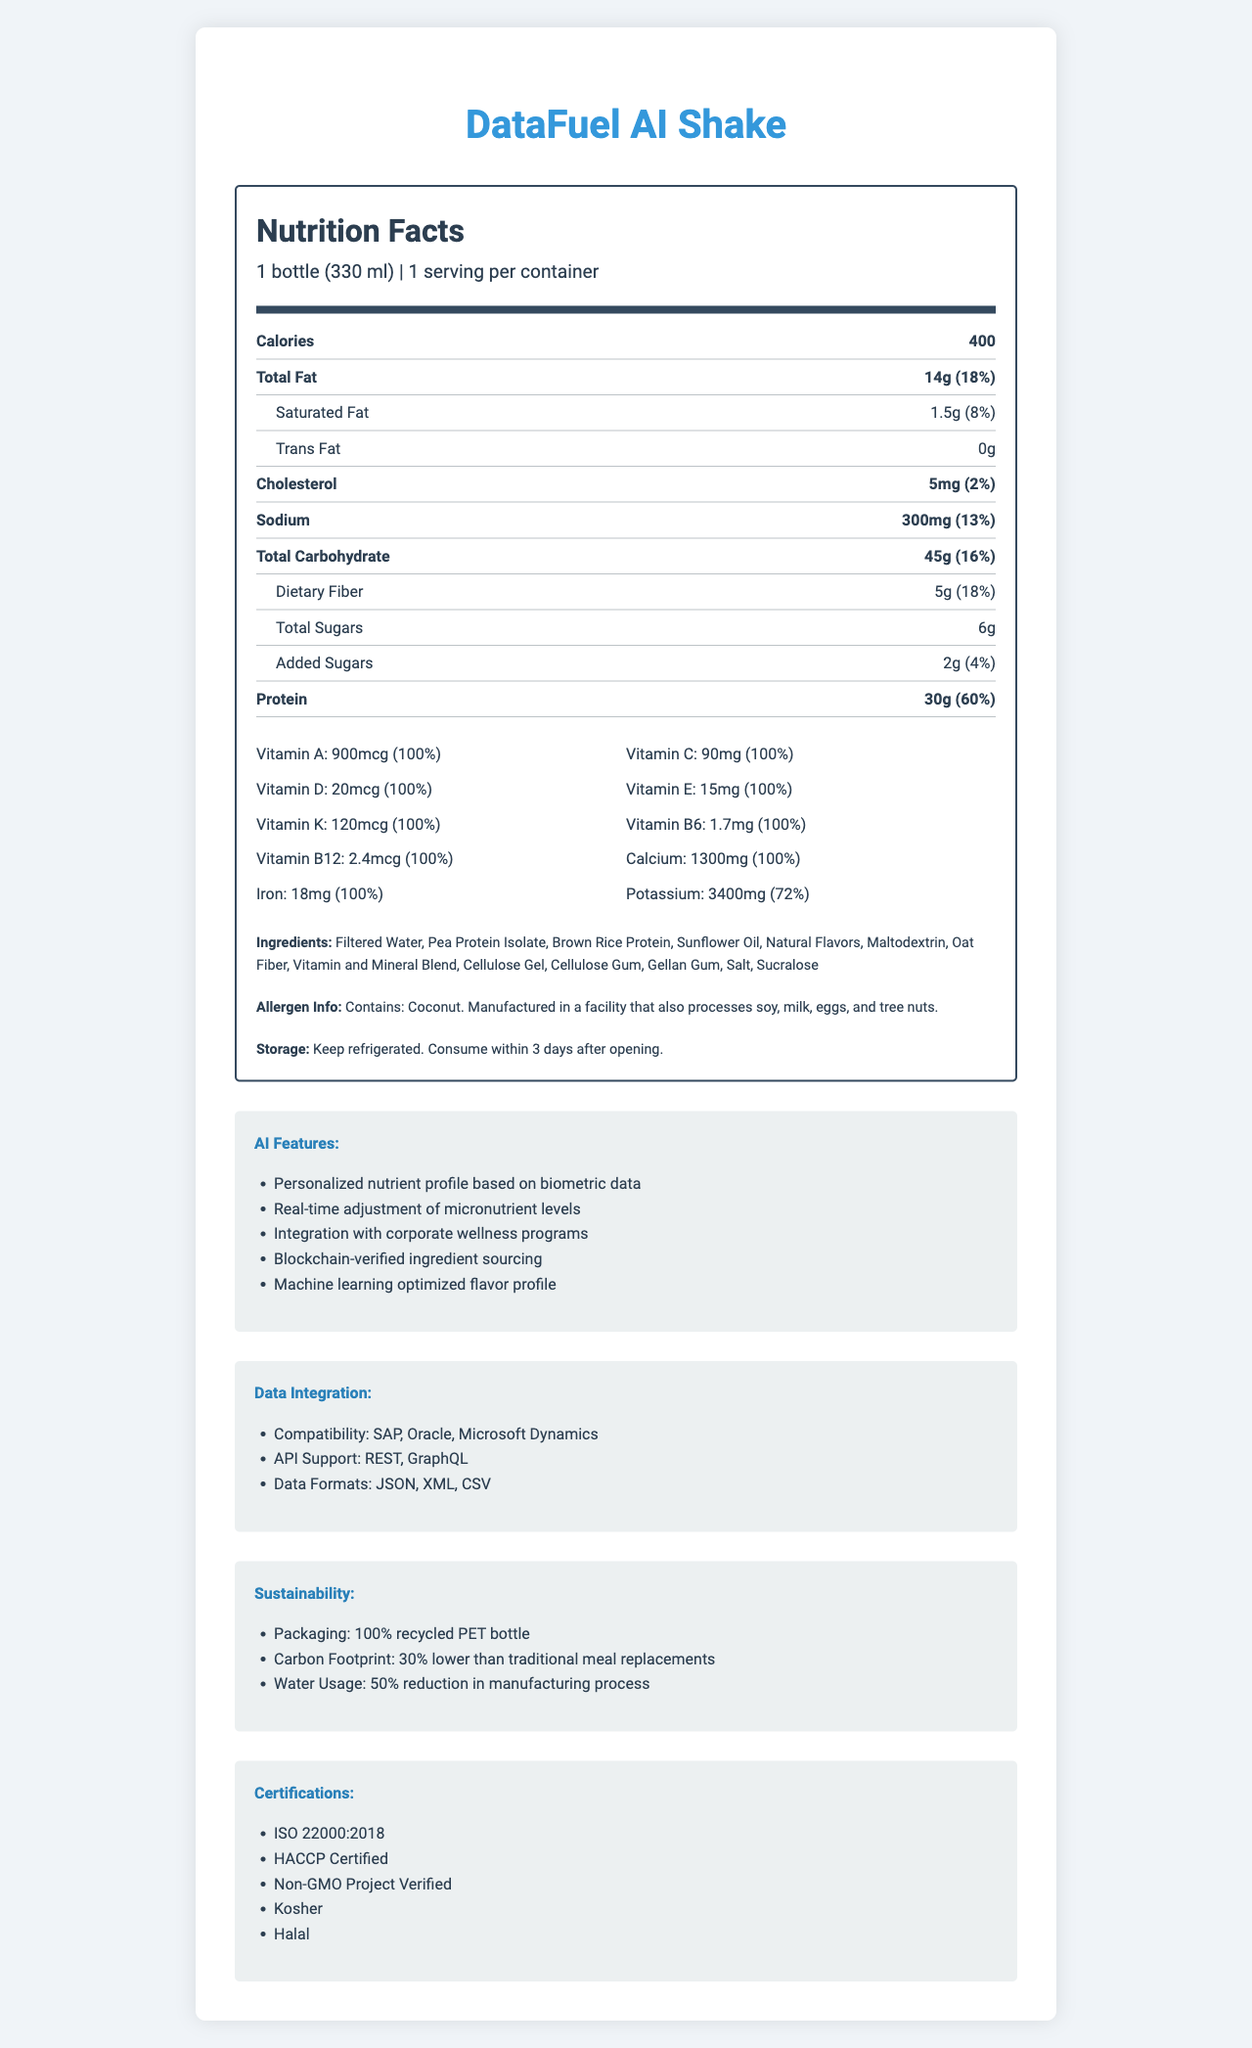what is the serving size for DataFuel AI Shake? The serving size is clearly mentioned in the section describing the serving information.
Answer: 1 bottle (330 ml) how many calories does one serving of DataFuel AI Shake contain? The calorie content is prominently listed under the main nutrients section.
Answer: 400 what is the amount of total fat in one serving? The amount of total fat is listed under the main nutrients section.
Answer: 14g how much added sugar is in one serving of DataFuel AI Shake? The amount of added sugars is specified in the sub-nutrient section.
Answer: 2g what is the daily value percentage of protein in one serving? The daily value percentage for protein is mentioned next to the protein amount.
Answer: 60% which of the following vitamins/minerals has a daily value of 100%? A. Vitamin A B. Vitamin C C. Calcium D. All of the above The document indicates that Vitamin A, Vitamin C, and Calcium each have a daily value of 100%.
Answer: D. All of the above which feature is not included in the AI functionalities? A. Personalized nutrient profile B. Real-time adjustment of micronutrient levels C. Blockchain-verified ingredient sourcing D. Automatic restocking The listed AI features do not mention anything about automatic restocking.
Answer: D. Automatic restocking is DataFuel AI Shake compatible with Microsoft Dynamics? Under data integration, it mentions compatibility with Microsoft Dynamics.
Answer: Yes summarize the key aspects of the DataFuel AI Shake. This summary includes key details about the product’s nutritional content, AI functionalities, data integrations, sustainability efforts, and certifications as described in the document.
Answer: DataFuel AI Shake is an AI-powered meal replacement shake that offers a detailed micronutrient breakdown. It contains 400 calories per serving with a well-balanced mix of macronutrients and 100% daily value of many essential vitamins and minerals. It includes advanced AI features and integrates with various data management systems. Additionally, it emphasizes sustainability with recycled packaging and reduced carbon footprint. The product is certified by multiple organizations including ISO and Non-GMO Project. what is the main source of protein in DataFuel AI Shake? The document lists ingredients like pea protein isolate and brown rice protein but does not specify which is the main source of protein.
Answer: Not enough information how long is the DataFuel AI Shake safe to consume after opening? Under storage instructions, it states to consume within 3 days after opening.
Answer: 3 days 